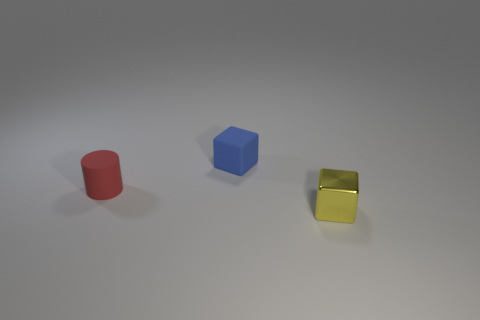Is there any other thing that is made of the same material as the yellow object?
Your answer should be very brief. No. What is the color of the matte thing that is the same size as the red matte cylinder?
Keep it short and to the point. Blue. Are there fewer blue matte objects that are in front of the tiny yellow metallic object than rubber blocks on the right side of the tiny blue object?
Offer a terse response. No. Do the shiny cube on the right side of the cylinder and the small red object have the same size?
Ensure brevity in your answer.  Yes. The small red rubber object that is to the left of the blue block has what shape?
Provide a succinct answer. Cylinder. Are there more tiny cyan blocks than small yellow metallic blocks?
Make the answer very short. No. Is the color of the block behind the red rubber thing the same as the tiny rubber cylinder?
Give a very brief answer. No. What number of objects are either blocks behind the yellow object or tiny objects in front of the blue object?
Keep it short and to the point. 3. What number of small objects are behind the yellow metal block and right of the small red object?
Provide a short and direct response. 1. Is the small blue cube made of the same material as the small yellow object?
Offer a terse response. No. 